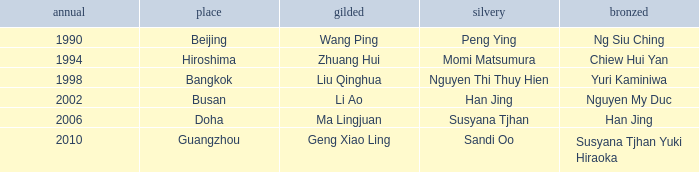What Gold has the Year of 1994? Zhuang Hui. 